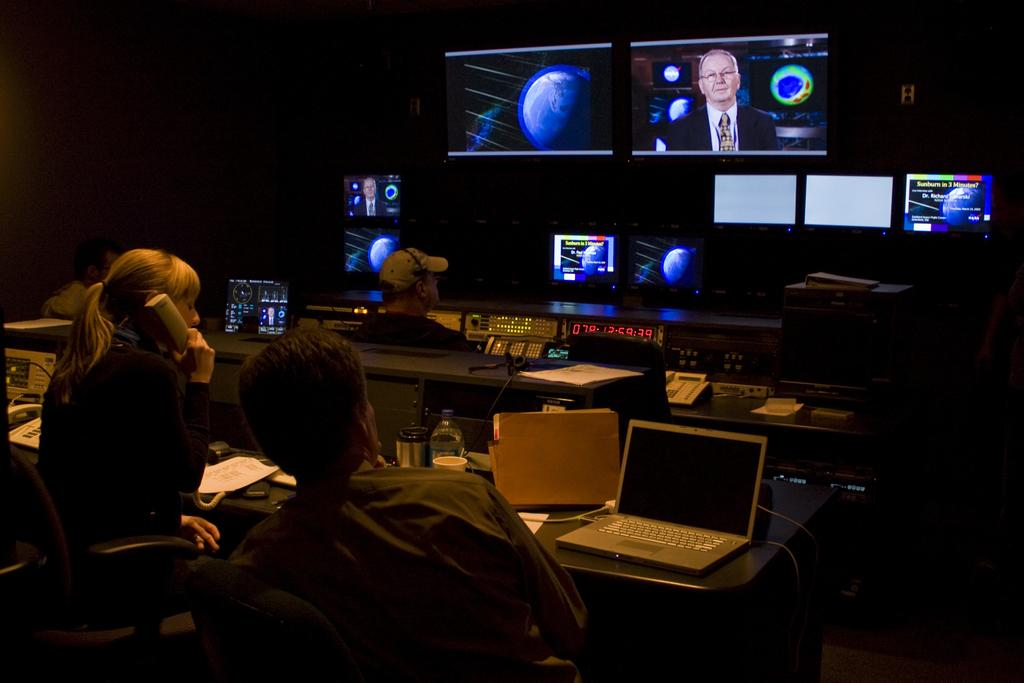<image>
Create a compact narrative representing the image presented. A dark room has three people looking at several screens on the wall, one of the screens says Sunburn in 3 Minutes?. 